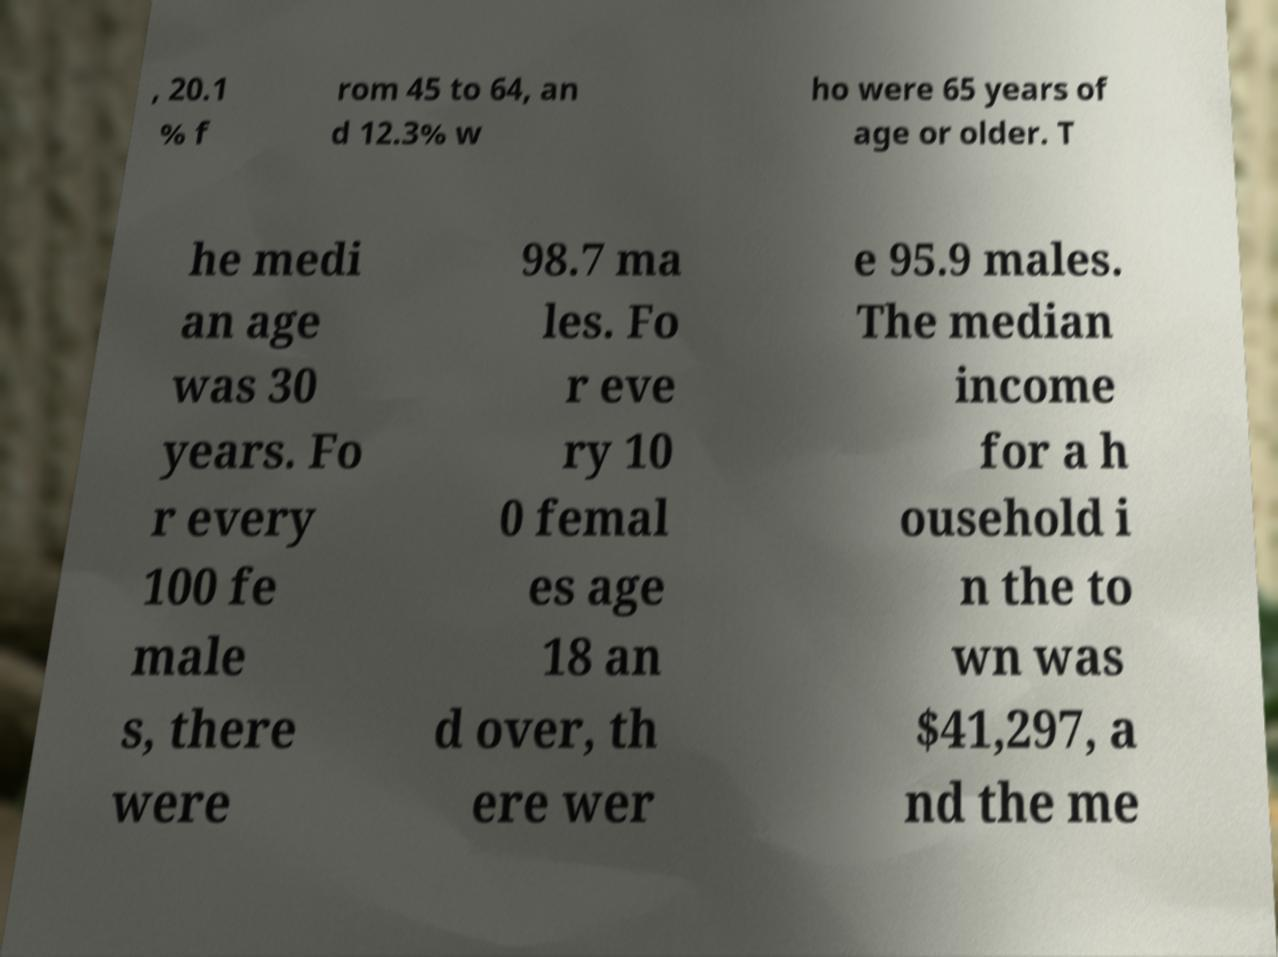Please identify and transcribe the text found in this image. , 20.1 % f rom 45 to 64, an d 12.3% w ho were 65 years of age or older. T he medi an age was 30 years. Fo r every 100 fe male s, there were 98.7 ma les. Fo r eve ry 10 0 femal es age 18 an d over, th ere wer e 95.9 males. The median income for a h ousehold i n the to wn was $41,297, a nd the me 